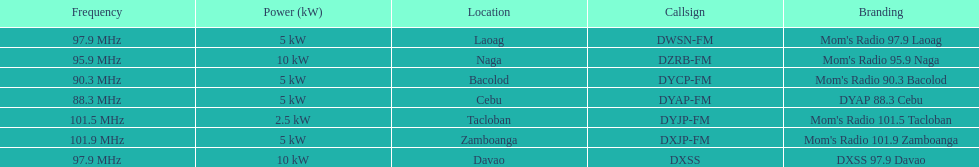What is the radio with the most mhz? Mom's Radio 101.9 Zamboanga. 